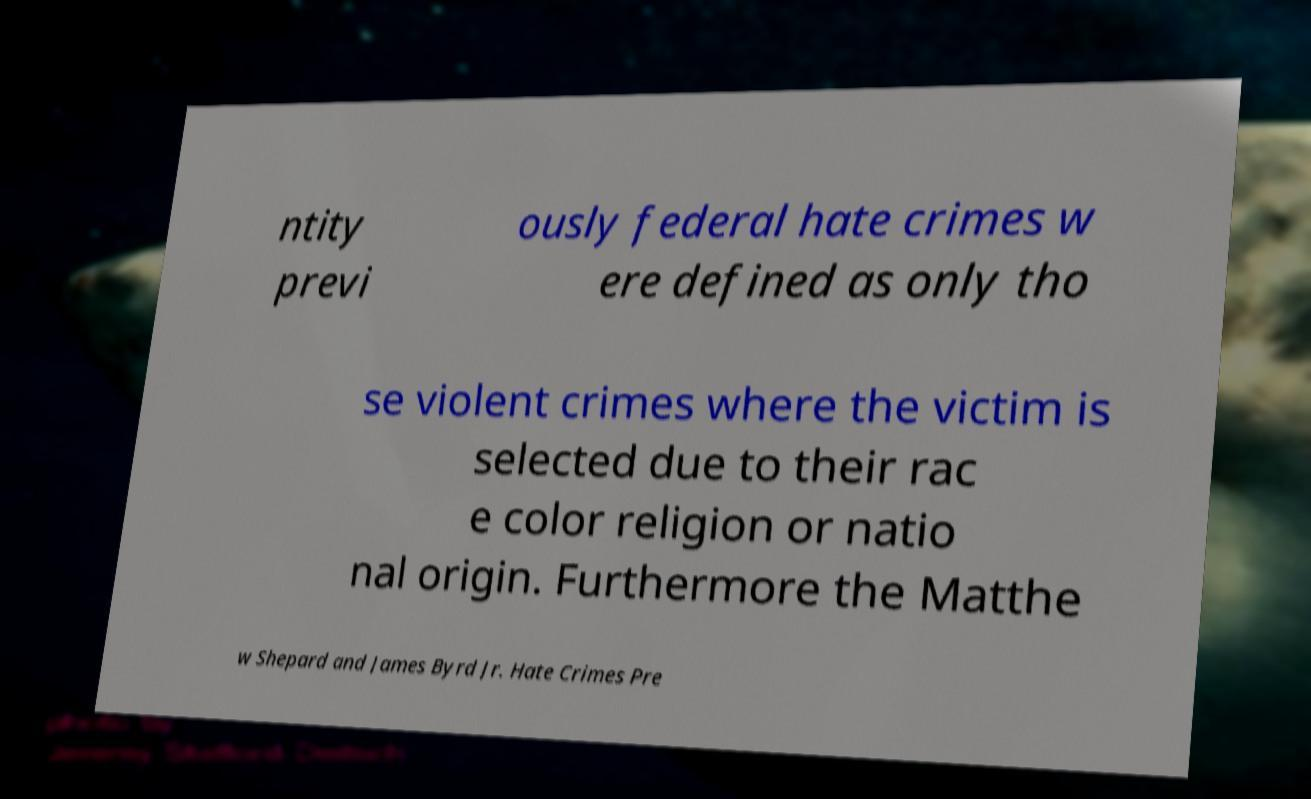Can you read and provide the text displayed in the image?This photo seems to have some interesting text. Can you extract and type it out for me? ntity previ ously federal hate crimes w ere defined as only tho se violent crimes where the victim is selected due to their rac e color religion or natio nal origin. Furthermore the Matthe w Shepard and James Byrd Jr. Hate Crimes Pre 